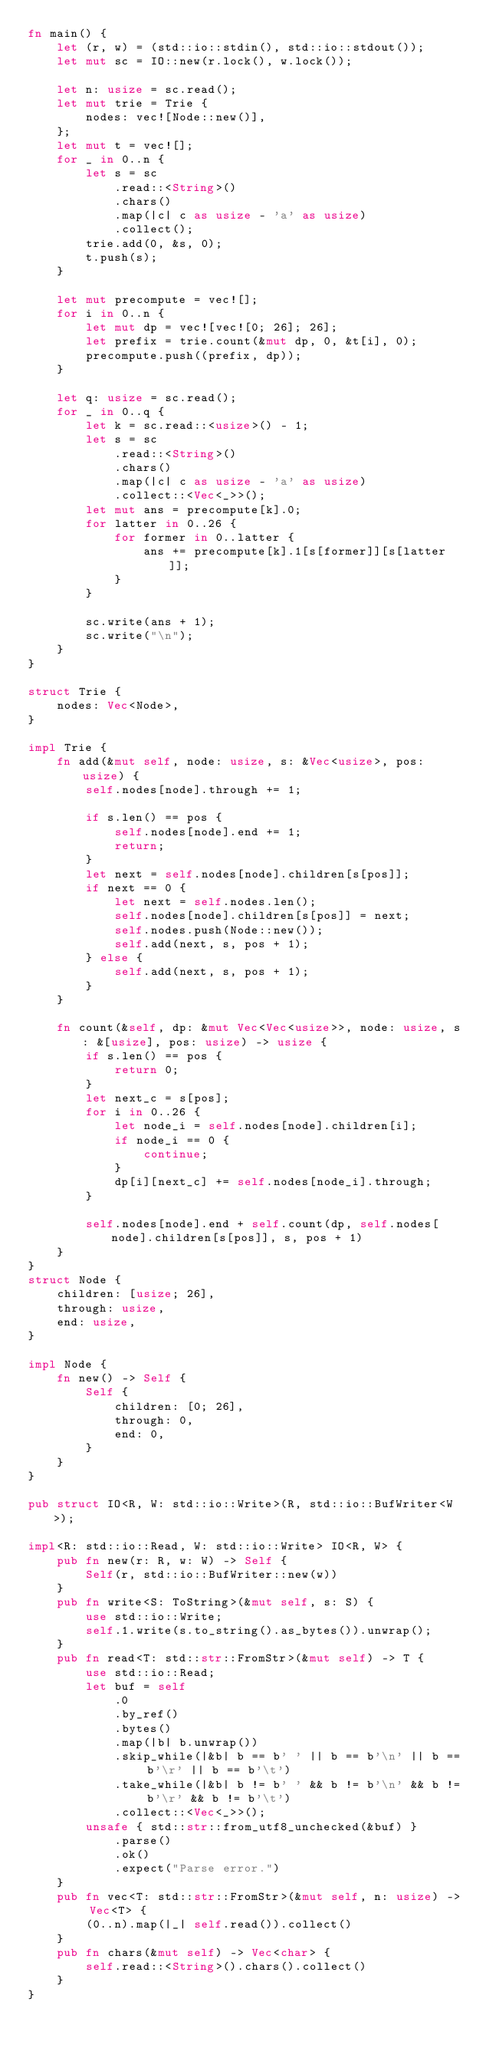Convert code to text. <code><loc_0><loc_0><loc_500><loc_500><_Rust_>fn main() {
    let (r, w) = (std::io::stdin(), std::io::stdout());
    let mut sc = IO::new(r.lock(), w.lock());

    let n: usize = sc.read();
    let mut trie = Trie {
        nodes: vec![Node::new()],
    };
    let mut t = vec![];
    for _ in 0..n {
        let s = sc
            .read::<String>()
            .chars()
            .map(|c| c as usize - 'a' as usize)
            .collect();
        trie.add(0, &s, 0);
        t.push(s);
    }

    let mut precompute = vec![];
    for i in 0..n {
        let mut dp = vec![vec![0; 26]; 26];
        let prefix = trie.count(&mut dp, 0, &t[i], 0);
        precompute.push((prefix, dp));
    }

    let q: usize = sc.read();
    for _ in 0..q {
        let k = sc.read::<usize>() - 1;
        let s = sc
            .read::<String>()
            .chars()
            .map(|c| c as usize - 'a' as usize)
            .collect::<Vec<_>>();
        let mut ans = precompute[k].0;
        for latter in 0..26 {
            for former in 0..latter {
                ans += precompute[k].1[s[former]][s[latter]];
            }
        }

        sc.write(ans + 1);
        sc.write("\n");
    }
}

struct Trie {
    nodes: Vec<Node>,
}

impl Trie {
    fn add(&mut self, node: usize, s: &Vec<usize>, pos: usize) {
        self.nodes[node].through += 1;

        if s.len() == pos {
            self.nodes[node].end += 1;
            return;
        }
        let next = self.nodes[node].children[s[pos]];
        if next == 0 {
            let next = self.nodes.len();
            self.nodes[node].children[s[pos]] = next;
            self.nodes.push(Node::new());
            self.add(next, s, pos + 1);
        } else {
            self.add(next, s, pos + 1);
        }
    }

    fn count(&self, dp: &mut Vec<Vec<usize>>, node: usize, s: &[usize], pos: usize) -> usize {
        if s.len() == pos {
            return 0;
        }
        let next_c = s[pos];
        for i in 0..26 {
            let node_i = self.nodes[node].children[i];
            if node_i == 0 {
                continue;
            }
            dp[i][next_c] += self.nodes[node_i].through;
        }

        self.nodes[node].end + self.count(dp, self.nodes[node].children[s[pos]], s, pos + 1)
    }
}
struct Node {
    children: [usize; 26],
    through: usize,
    end: usize,
}

impl Node {
    fn new() -> Self {
        Self {
            children: [0; 26],
            through: 0,
            end: 0,
        }
    }
}

pub struct IO<R, W: std::io::Write>(R, std::io::BufWriter<W>);

impl<R: std::io::Read, W: std::io::Write> IO<R, W> {
    pub fn new(r: R, w: W) -> Self {
        Self(r, std::io::BufWriter::new(w))
    }
    pub fn write<S: ToString>(&mut self, s: S) {
        use std::io::Write;
        self.1.write(s.to_string().as_bytes()).unwrap();
    }
    pub fn read<T: std::str::FromStr>(&mut self) -> T {
        use std::io::Read;
        let buf = self
            .0
            .by_ref()
            .bytes()
            .map(|b| b.unwrap())
            .skip_while(|&b| b == b' ' || b == b'\n' || b == b'\r' || b == b'\t')
            .take_while(|&b| b != b' ' && b != b'\n' && b != b'\r' && b != b'\t')
            .collect::<Vec<_>>();
        unsafe { std::str::from_utf8_unchecked(&buf) }
            .parse()
            .ok()
            .expect("Parse error.")
    }
    pub fn vec<T: std::str::FromStr>(&mut self, n: usize) -> Vec<T> {
        (0..n).map(|_| self.read()).collect()
    }
    pub fn chars(&mut self) -> Vec<char> {
        self.read::<String>().chars().collect()
    }
}
</code> 